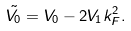Convert formula to latex. <formula><loc_0><loc_0><loc_500><loc_500>\tilde { V _ { 0 } } = V _ { 0 } - 2 V _ { 1 } k _ { F } ^ { 2 } .</formula> 